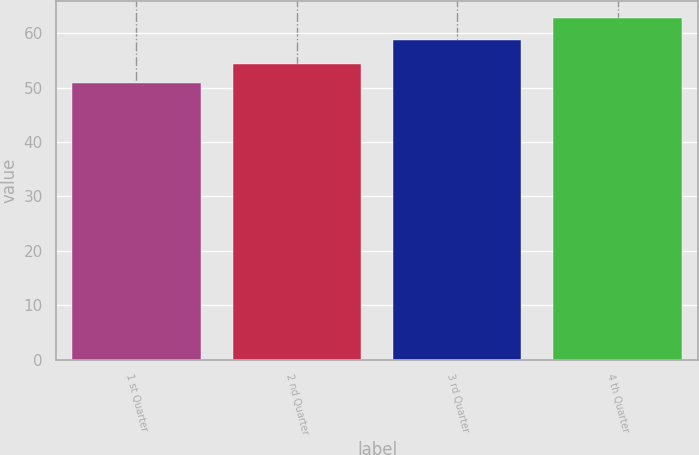Convert chart. <chart><loc_0><loc_0><loc_500><loc_500><bar_chart><fcel>1 st Quarter<fcel>2 nd Quarter<fcel>3 rd Quarter<fcel>4 th Quarter<nl><fcel>50.9<fcel>54.36<fcel>58.79<fcel>62.74<nl></chart> 